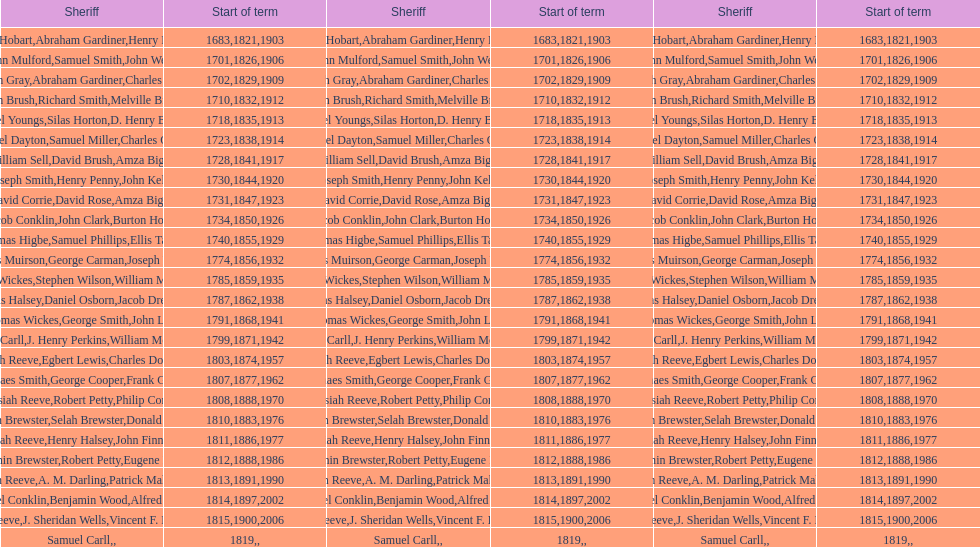How sheriffs has suffolk county had in total? 76. 